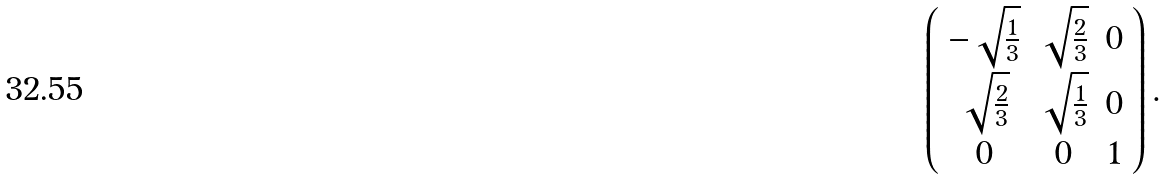Convert formula to latex. <formula><loc_0><loc_0><loc_500><loc_500>\left ( \begin{array} { c c c } - \sqrt { \frac { 1 } { 3 } } & \sqrt { \frac { 2 } { 3 } } & 0 \\ \sqrt { \frac { 2 } { 3 } } & \sqrt { \frac { 1 } { 3 } } & 0 \\ 0 & 0 & 1 \\ \end{array} \right ) .</formula> 